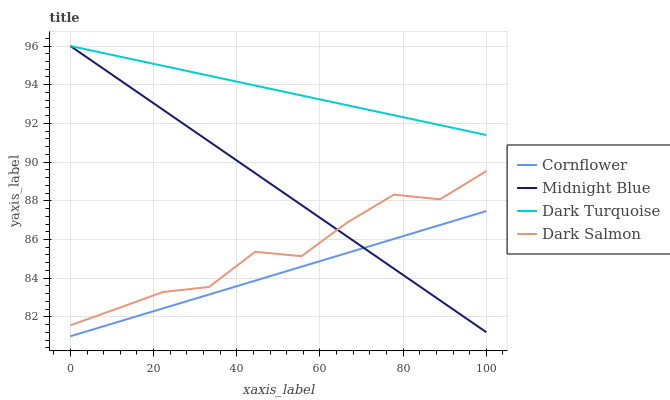Does Cornflower have the minimum area under the curve?
Answer yes or no. Yes. Does Dark Turquoise have the maximum area under the curve?
Answer yes or no. Yes. Does Dark Salmon have the minimum area under the curve?
Answer yes or no. No. Does Dark Salmon have the maximum area under the curve?
Answer yes or no. No. Is Cornflower the smoothest?
Answer yes or no. Yes. Is Dark Salmon the roughest?
Answer yes or no. Yes. Is Midnight Blue the smoothest?
Answer yes or no. No. Is Midnight Blue the roughest?
Answer yes or no. No. Does Cornflower have the lowest value?
Answer yes or no. Yes. Does Dark Salmon have the lowest value?
Answer yes or no. No. Does Dark Turquoise have the highest value?
Answer yes or no. Yes. Does Dark Salmon have the highest value?
Answer yes or no. No. Is Cornflower less than Dark Salmon?
Answer yes or no. Yes. Is Dark Turquoise greater than Dark Salmon?
Answer yes or no. Yes. Does Dark Salmon intersect Midnight Blue?
Answer yes or no. Yes. Is Dark Salmon less than Midnight Blue?
Answer yes or no. No. Is Dark Salmon greater than Midnight Blue?
Answer yes or no. No. Does Cornflower intersect Dark Salmon?
Answer yes or no. No. 